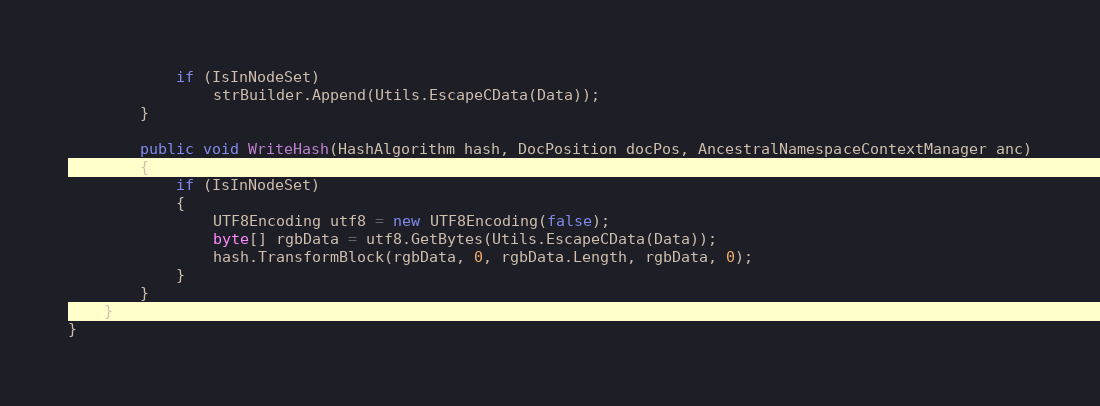Convert code to text. <code><loc_0><loc_0><loc_500><loc_500><_C#_>            if (IsInNodeSet)
                strBuilder.Append(Utils.EscapeCData(Data));
        }

        public void WriteHash(HashAlgorithm hash, DocPosition docPos, AncestralNamespaceContextManager anc)
        {
            if (IsInNodeSet)
            {
                UTF8Encoding utf8 = new UTF8Encoding(false);
                byte[] rgbData = utf8.GetBytes(Utils.EscapeCData(Data));
                hash.TransformBlock(rgbData, 0, rgbData.Length, rgbData, 0);
            }
        }
    }
}
</code> 